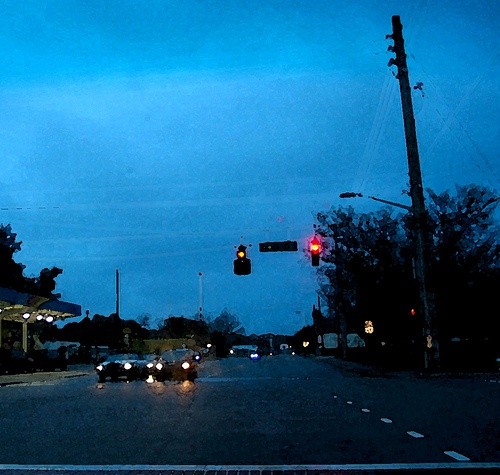Describe the objects in this image and their specific colors. I can see car in lightblue, black, blue, gray, and white tones, car in lightblue, black, blue, darkblue, and white tones, car in lightblue, black, darkblue, blue, and darkgreen tones, traffic light in lightblue, black, purple, red, and violet tones, and traffic light in lightblue, black, yellow, blue, and teal tones in this image. 